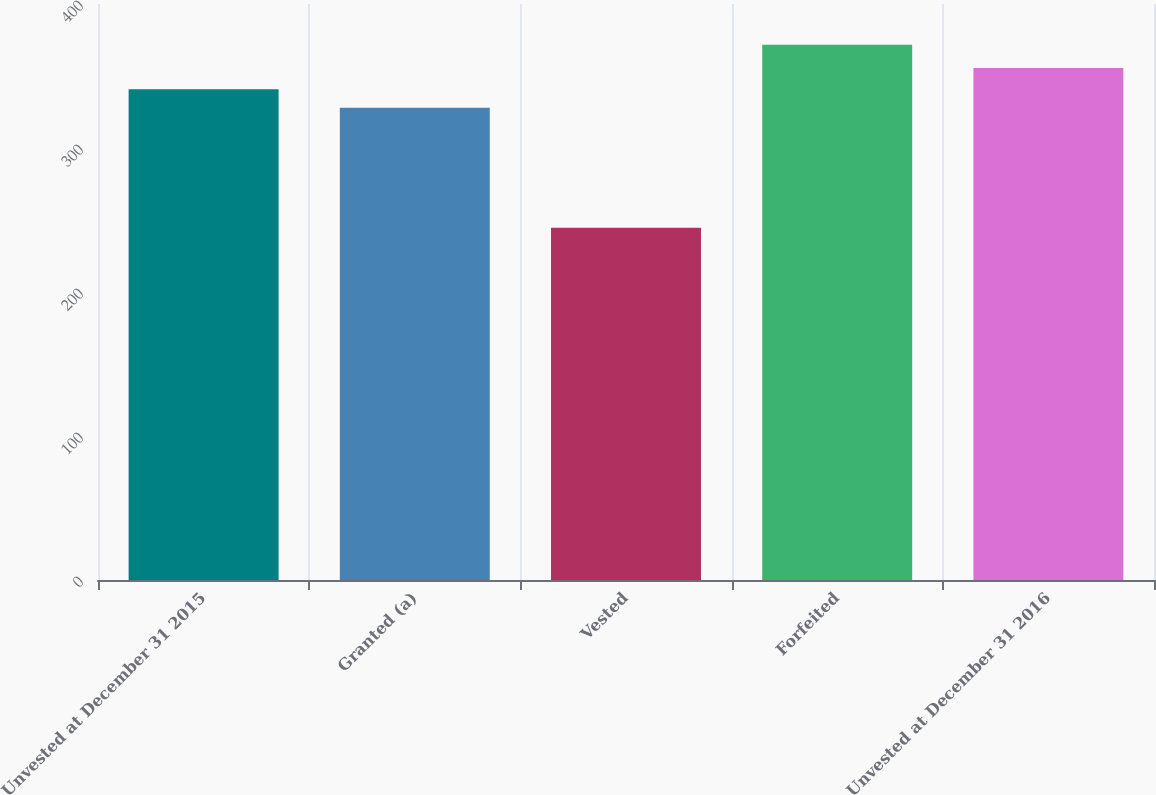<chart> <loc_0><loc_0><loc_500><loc_500><bar_chart><fcel>Unvested at December 31 2015<fcel>Granted (a)<fcel>Vested<fcel>Forfeited<fcel>Unvested at December 31 2016<nl><fcel>340.72<fcel>328.03<fcel>244.68<fcel>371.62<fcel>355.6<nl></chart> 